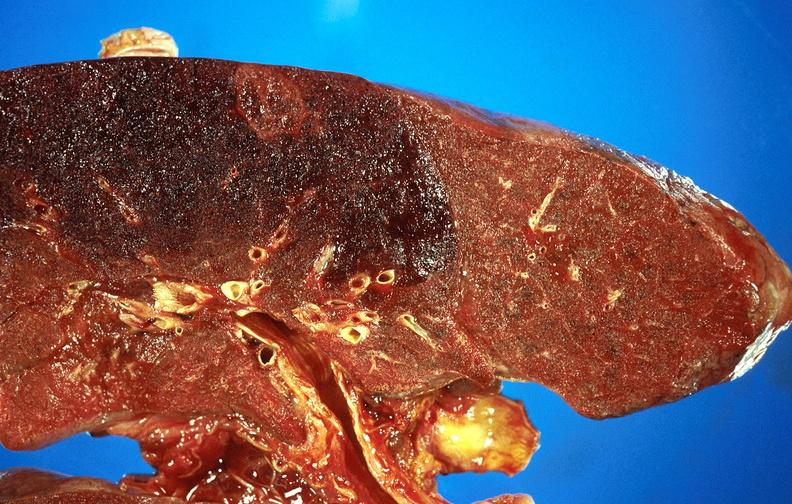what is present?
Answer the question using a single word or phrase. Respiratory 